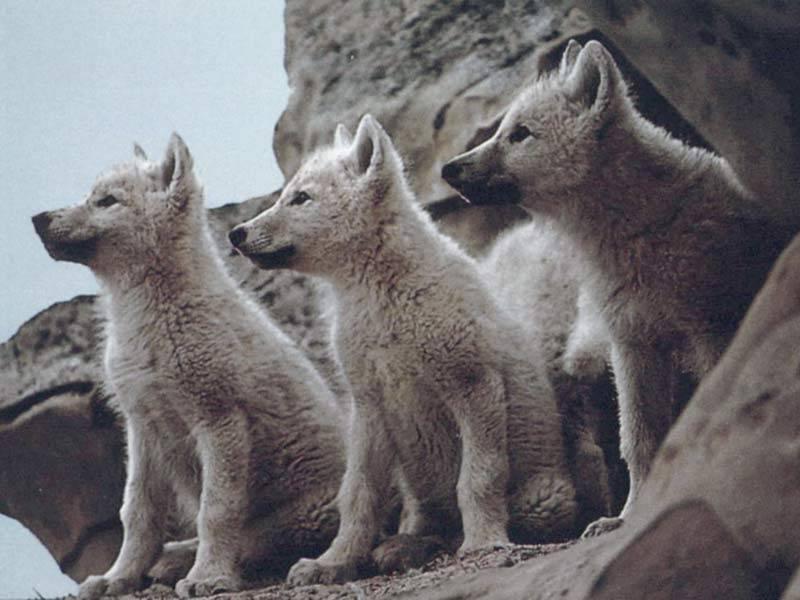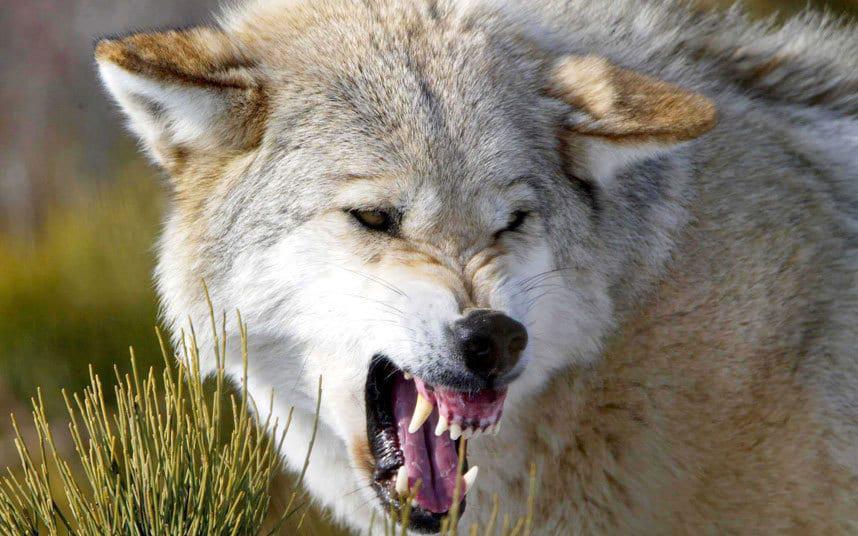The first image is the image on the left, the second image is the image on the right. Evaluate the accuracy of this statement regarding the images: "An image shows at least one wolf gazing directly leftward.". Is it true? Answer yes or no. Yes. 